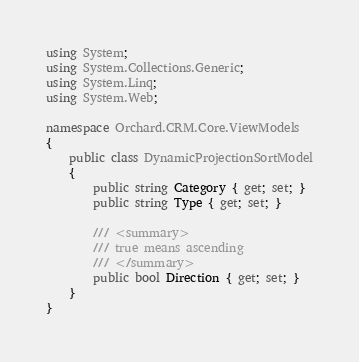Convert code to text. <code><loc_0><loc_0><loc_500><loc_500><_C#_>using System;
using System.Collections.Generic;
using System.Linq;
using System.Web;

namespace Orchard.CRM.Core.ViewModels
{
    public class DynamicProjectionSortModel
    {
        public string Category { get; set; }
        public string Type { get; set; }

        /// <summary>
        /// true means ascending
        /// </summary>
        public bool Direction { get; set; }
    }
}</code> 